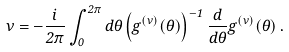Convert formula to latex. <formula><loc_0><loc_0><loc_500><loc_500>\nu = - \frac { i } { 2 \pi } \int _ { 0 } ^ { 2 \pi } d \theta \left ( g ^ { ( \nu ) } ( \theta ) \right ) ^ { - 1 } \frac { d } { d \theta } g ^ { ( \nu ) } ( \theta ) \, .</formula> 